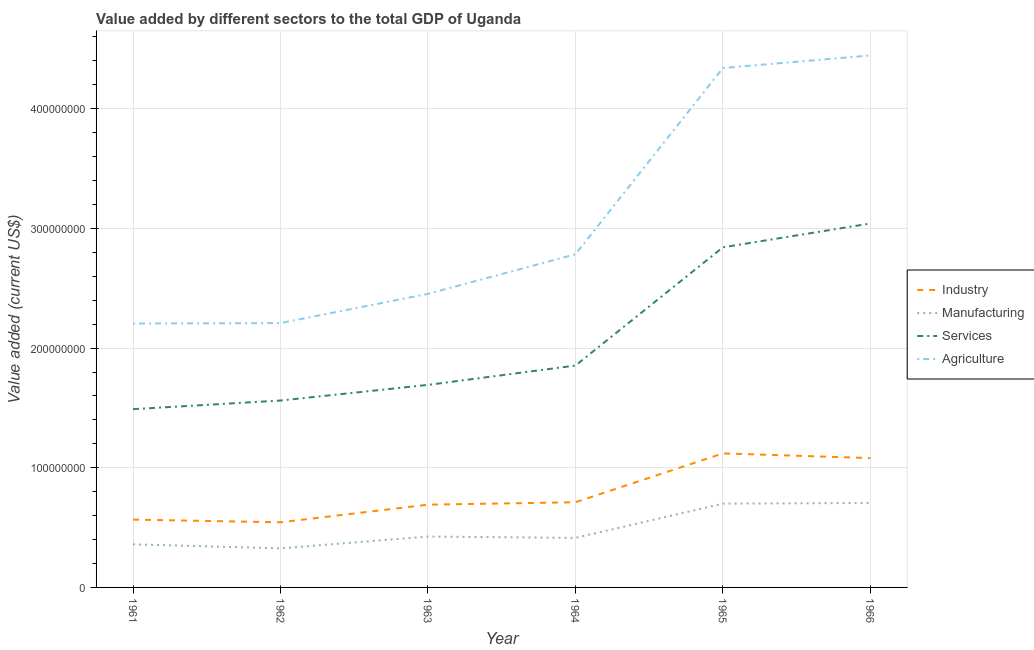What is the value added by agricultural sector in 1966?
Provide a succinct answer. 4.44e+08. Across all years, what is the maximum value added by agricultural sector?
Your answer should be compact. 4.44e+08. Across all years, what is the minimum value added by manufacturing sector?
Make the answer very short. 3.26e+07. In which year was the value added by industrial sector maximum?
Provide a succinct answer. 1965. What is the total value added by services sector in the graph?
Provide a succinct answer. 1.25e+09. What is the difference between the value added by industrial sector in 1962 and that in 1963?
Keep it short and to the point. -1.47e+07. What is the difference between the value added by agricultural sector in 1962 and the value added by industrial sector in 1964?
Ensure brevity in your answer.  1.50e+08. What is the average value added by manufacturing sector per year?
Give a very brief answer. 4.89e+07. In the year 1963, what is the difference between the value added by agricultural sector and value added by services sector?
Your answer should be compact. 7.61e+07. In how many years, is the value added by services sector greater than 100000000 US$?
Offer a terse response. 6. What is the ratio of the value added by industrial sector in 1965 to that in 1966?
Your response must be concise. 1.04. Is the value added by agricultural sector in 1962 less than that in 1965?
Your answer should be very brief. Yes. What is the difference between the highest and the second highest value added by agricultural sector?
Provide a succinct answer. 1.05e+07. What is the difference between the highest and the lowest value added by industrial sector?
Give a very brief answer. 5.76e+07. In how many years, is the value added by manufacturing sector greater than the average value added by manufacturing sector taken over all years?
Your response must be concise. 2. Is it the case that in every year, the sum of the value added by industrial sector and value added by manufacturing sector is greater than the value added by services sector?
Keep it short and to the point. No. Does the value added by agricultural sector monotonically increase over the years?
Provide a short and direct response. Yes. Is the value added by services sector strictly less than the value added by agricultural sector over the years?
Provide a succinct answer. Yes. How many lines are there?
Provide a short and direct response. 4. What is the difference between two consecutive major ticks on the Y-axis?
Offer a very short reply. 1.00e+08. How many legend labels are there?
Your answer should be compact. 4. How are the legend labels stacked?
Give a very brief answer. Vertical. What is the title of the graph?
Provide a short and direct response. Value added by different sectors to the total GDP of Uganda. What is the label or title of the X-axis?
Offer a very short reply. Year. What is the label or title of the Y-axis?
Offer a terse response. Value added (current US$). What is the Value added (current US$) in Industry in 1961?
Give a very brief answer. 5.67e+07. What is the Value added (current US$) of Manufacturing in 1961?
Give a very brief answer. 3.60e+07. What is the Value added (current US$) of Services in 1961?
Give a very brief answer. 1.49e+08. What is the Value added (current US$) in Agriculture in 1961?
Offer a very short reply. 2.20e+08. What is the Value added (current US$) of Industry in 1962?
Your answer should be very brief. 5.44e+07. What is the Value added (current US$) in Manufacturing in 1962?
Provide a succinct answer. 3.26e+07. What is the Value added (current US$) in Services in 1962?
Give a very brief answer. 1.56e+08. What is the Value added (current US$) of Agriculture in 1962?
Keep it short and to the point. 2.21e+08. What is the Value added (current US$) in Industry in 1963?
Your answer should be very brief. 6.91e+07. What is the Value added (current US$) of Manufacturing in 1963?
Make the answer very short. 4.25e+07. What is the Value added (current US$) of Services in 1963?
Keep it short and to the point. 1.69e+08. What is the Value added (current US$) in Agriculture in 1963?
Your answer should be compact. 2.45e+08. What is the Value added (current US$) in Industry in 1964?
Ensure brevity in your answer.  7.12e+07. What is the Value added (current US$) in Manufacturing in 1964?
Provide a succinct answer. 4.14e+07. What is the Value added (current US$) of Services in 1964?
Your answer should be compact. 1.85e+08. What is the Value added (current US$) of Agriculture in 1964?
Keep it short and to the point. 2.78e+08. What is the Value added (current US$) in Industry in 1965?
Make the answer very short. 1.12e+08. What is the Value added (current US$) in Manufacturing in 1965?
Your answer should be very brief. 7.00e+07. What is the Value added (current US$) in Services in 1965?
Your answer should be very brief. 2.84e+08. What is the Value added (current US$) of Agriculture in 1965?
Provide a short and direct response. 4.34e+08. What is the Value added (current US$) in Industry in 1966?
Offer a very short reply. 1.08e+08. What is the Value added (current US$) in Manufacturing in 1966?
Your answer should be very brief. 7.06e+07. What is the Value added (current US$) in Services in 1966?
Provide a succinct answer. 3.04e+08. What is the Value added (current US$) in Agriculture in 1966?
Your answer should be compact. 4.44e+08. Across all years, what is the maximum Value added (current US$) of Industry?
Ensure brevity in your answer.  1.12e+08. Across all years, what is the maximum Value added (current US$) in Manufacturing?
Your response must be concise. 7.06e+07. Across all years, what is the maximum Value added (current US$) of Services?
Your answer should be compact. 3.04e+08. Across all years, what is the maximum Value added (current US$) of Agriculture?
Offer a terse response. 4.44e+08. Across all years, what is the minimum Value added (current US$) in Industry?
Make the answer very short. 5.44e+07. Across all years, what is the minimum Value added (current US$) in Manufacturing?
Make the answer very short. 3.26e+07. Across all years, what is the minimum Value added (current US$) in Services?
Give a very brief answer. 1.49e+08. Across all years, what is the minimum Value added (current US$) in Agriculture?
Ensure brevity in your answer.  2.20e+08. What is the total Value added (current US$) in Industry in the graph?
Keep it short and to the point. 4.71e+08. What is the total Value added (current US$) in Manufacturing in the graph?
Your answer should be compact. 2.93e+08. What is the total Value added (current US$) in Services in the graph?
Offer a very short reply. 1.25e+09. What is the total Value added (current US$) of Agriculture in the graph?
Ensure brevity in your answer.  1.84e+09. What is the difference between the Value added (current US$) of Industry in 1961 and that in 1962?
Your answer should be compact. 2.24e+06. What is the difference between the Value added (current US$) in Manufacturing in 1961 and that in 1962?
Your response must be concise. 3.39e+06. What is the difference between the Value added (current US$) in Services in 1961 and that in 1962?
Make the answer very short. -7.22e+06. What is the difference between the Value added (current US$) of Agriculture in 1961 and that in 1962?
Ensure brevity in your answer.  -4.07e+05. What is the difference between the Value added (current US$) in Industry in 1961 and that in 1963?
Provide a succinct answer. -1.25e+07. What is the difference between the Value added (current US$) of Manufacturing in 1961 and that in 1963?
Your response must be concise. -6.48e+06. What is the difference between the Value added (current US$) in Services in 1961 and that in 1963?
Keep it short and to the point. -2.03e+07. What is the difference between the Value added (current US$) in Agriculture in 1961 and that in 1963?
Your answer should be very brief. -2.48e+07. What is the difference between the Value added (current US$) in Industry in 1961 and that in 1964?
Give a very brief answer. -1.45e+07. What is the difference between the Value added (current US$) of Manufacturing in 1961 and that in 1964?
Provide a short and direct response. -5.37e+06. What is the difference between the Value added (current US$) in Services in 1961 and that in 1964?
Provide a succinct answer. -3.64e+07. What is the difference between the Value added (current US$) of Agriculture in 1961 and that in 1964?
Offer a terse response. -5.79e+07. What is the difference between the Value added (current US$) of Industry in 1961 and that in 1965?
Provide a succinct answer. -5.53e+07. What is the difference between the Value added (current US$) in Manufacturing in 1961 and that in 1965?
Keep it short and to the point. -3.40e+07. What is the difference between the Value added (current US$) in Services in 1961 and that in 1965?
Your answer should be compact. -1.35e+08. What is the difference between the Value added (current US$) in Agriculture in 1961 and that in 1965?
Your response must be concise. -2.13e+08. What is the difference between the Value added (current US$) in Industry in 1961 and that in 1966?
Give a very brief answer. -5.14e+07. What is the difference between the Value added (current US$) in Manufacturing in 1961 and that in 1966?
Offer a very short reply. -3.45e+07. What is the difference between the Value added (current US$) in Services in 1961 and that in 1966?
Provide a short and direct response. -1.55e+08. What is the difference between the Value added (current US$) of Agriculture in 1961 and that in 1966?
Provide a succinct answer. -2.24e+08. What is the difference between the Value added (current US$) in Industry in 1962 and that in 1963?
Ensure brevity in your answer.  -1.47e+07. What is the difference between the Value added (current US$) in Manufacturing in 1962 and that in 1963?
Your answer should be compact. -9.87e+06. What is the difference between the Value added (current US$) in Services in 1962 and that in 1963?
Give a very brief answer. -1.31e+07. What is the difference between the Value added (current US$) of Agriculture in 1962 and that in 1963?
Your answer should be compact. -2.44e+07. What is the difference between the Value added (current US$) in Industry in 1962 and that in 1964?
Keep it short and to the point. -1.68e+07. What is the difference between the Value added (current US$) in Manufacturing in 1962 and that in 1964?
Your answer should be very brief. -8.76e+06. What is the difference between the Value added (current US$) of Services in 1962 and that in 1964?
Give a very brief answer. -2.92e+07. What is the difference between the Value added (current US$) in Agriculture in 1962 and that in 1964?
Offer a terse response. -5.75e+07. What is the difference between the Value added (current US$) of Industry in 1962 and that in 1965?
Keep it short and to the point. -5.76e+07. What is the difference between the Value added (current US$) of Manufacturing in 1962 and that in 1965?
Offer a terse response. -3.74e+07. What is the difference between the Value added (current US$) of Services in 1962 and that in 1965?
Ensure brevity in your answer.  -1.28e+08. What is the difference between the Value added (current US$) in Agriculture in 1962 and that in 1965?
Ensure brevity in your answer.  -2.13e+08. What is the difference between the Value added (current US$) in Industry in 1962 and that in 1966?
Your answer should be very brief. -5.37e+07. What is the difference between the Value added (current US$) of Manufacturing in 1962 and that in 1966?
Keep it short and to the point. -3.79e+07. What is the difference between the Value added (current US$) in Services in 1962 and that in 1966?
Make the answer very short. -1.48e+08. What is the difference between the Value added (current US$) in Agriculture in 1962 and that in 1966?
Your response must be concise. -2.24e+08. What is the difference between the Value added (current US$) in Industry in 1963 and that in 1964?
Provide a succinct answer. -2.03e+06. What is the difference between the Value added (current US$) of Manufacturing in 1963 and that in 1964?
Your response must be concise. 1.11e+06. What is the difference between the Value added (current US$) in Services in 1963 and that in 1964?
Provide a short and direct response. -1.61e+07. What is the difference between the Value added (current US$) in Agriculture in 1963 and that in 1964?
Keep it short and to the point. -3.31e+07. What is the difference between the Value added (current US$) of Industry in 1963 and that in 1965?
Keep it short and to the point. -4.29e+07. What is the difference between the Value added (current US$) of Manufacturing in 1963 and that in 1965?
Provide a succinct answer. -2.75e+07. What is the difference between the Value added (current US$) of Services in 1963 and that in 1965?
Your response must be concise. -1.15e+08. What is the difference between the Value added (current US$) in Agriculture in 1963 and that in 1965?
Make the answer very short. -1.89e+08. What is the difference between the Value added (current US$) of Industry in 1963 and that in 1966?
Your answer should be compact. -3.89e+07. What is the difference between the Value added (current US$) of Manufacturing in 1963 and that in 1966?
Offer a very short reply. -2.81e+07. What is the difference between the Value added (current US$) in Services in 1963 and that in 1966?
Offer a very short reply. -1.35e+08. What is the difference between the Value added (current US$) of Agriculture in 1963 and that in 1966?
Provide a succinct answer. -1.99e+08. What is the difference between the Value added (current US$) in Industry in 1964 and that in 1965?
Your answer should be very brief. -4.08e+07. What is the difference between the Value added (current US$) of Manufacturing in 1964 and that in 1965?
Give a very brief answer. -2.86e+07. What is the difference between the Value added (current US$) of Services in 1964 and that in 1965?
Ensure brevity in your answer.  -9.88e+07. What is the difference between the Value added (current US$) in Agriculture in 1964 and that in 1965?
Your answer should be compact. -1.56e+08. What is the difference between the Value added (current US$) in Industry in 1964 and that in 1966?
Offer a terse response. -3.69e+07. What is the difference between the Value added (current US$) in Manufacturing in 1964 and that in 1966?
Ensure brevity in your answer.  -2.92e+07. What is the difference between the Value added (current US$) of Services in 1964 and that in 1966?
Ensure brevity in your answer.  -1.19e+08. What is the difference between the Value added (current US$) of Agriculture in 1964 and that in 1966?
Your answer should be very brief. -1.66e+08. What is the difference between the Value added (current US$) in Industry in 1965 and that in 1966?
Ensure brevity in your answer.  3.92e+06. What is the difference between the Value added (current US$) of Manufacturing in 1965 and that in 1966?
Provide a short and direct response. -5.60e+05. What is the difference between the Value added (current US$) of Services in 1965 and that in 1966?
Make the answer very short. -1.99e+07. What is the difference between the Value added (current US$) in Agriculture in 1965 and that in 1966?
Provide a short and direct response. -1.05e+07. What is the difference between the Value added (current US$) of Industry in 1961 and the Value added (current US$) of Manufacturing in 1962?
Give a very brief answer. 2.40e+07. What is the difference between the Value added (current US$) in Industry in 1961 and the Value added (current US$) in Services in 1962?
Your answer should be compact. -9.95e+07. What is the difference between the Value added (current US$) of Industry in 1961 and the Value added (current US$) of Agriculture in 1962?
Provide a short and direct response. -1.64e+08. What is the difference between the Value added (current US$) of Manufacturing in 1961 and the Value added (current US$) of Services in 1962?
Provide a short and direct response. -1.20e+08. What is the difference between the Value added (current US$) of Manufacturing in 1961 and the Value added (current US$) of Agriculture in 1962?
Offer a very short reply. -1.85e+08. What is the difference between the Value added (current US$) in Services in 1961 and the Value added (current US$) in Agriculture in 1962?
Make the answer very short. -7.20e+07. What is the difference between the Value added (current US$) in Industry in 1961 and the Value added (current US$) in Manufacturing in 1963?
Your answer should be very brief. 1.42e+07. What is the difference between the Value added (current US$) of Industry in 1961 and the Value added (current US$) of Services in 1963?
Provide a succinct answer. -1.13e+08. What is the difference between the Value added (current US$) in Industry in 1961 and the Value added (current US$) in Agriculture in 1963?
Your answer should be very brief. -1.89e+08. What is the difference between the Value added (current US$) in Manufacturing in 1961 and the Value added (current US$) in Services in 1963?
Ensure brevity in your answer.  -1.33e+08. What is the difference between the Value added (current US$) in Manufacturing in 1961 and the Value added (current US$) in Agriculture in 1963?
Your response must be concise. -2.09e+08. What is the difference between the Value added (current US$) of Services in 1961 and the Value added (current US$) of Agriculture in 1963?
Make the answer very short. -9.64e+07. What is the difference between the Value added (current US$) in Industry in 1961 and the Value added (current US$) in Manufacturing in 1964?
Your answer should be very brief. 1.53e+07. What is the difference between the Value added (current US$) of Industry in 1961 and the Value added (current US$) of Services in 1964?
Offer a terse response. -1.29e+08. What is the difference between the Value added (current US$) of Industry in 1961 and the Value added (current US$) of Agriculture in 1964?
Provide a succinct answer. -2.22e+08. What is the difference between the Value added (current US$) of Manufacturing in 1961 and the Value added (current US$) of Services in 1964?
Provide a succinct answer. -1.49e+08. What is the difference between the Value added (current US$) in Manufacturing in 1961 and the Value added (current US$) in Agriculture in 1964?
Your answer should be very brief. -2.42e+08. What is the difference between the Value added (current US$) of Services in 1961 and the Value added (current US$) of Agriculture in 1964?
Ensure brevity in your answer.  -1.29e+08. What is the difference between the Value added (current US$) of Industry in 1961 and the Value added (current US$) of Manufacturing in 1965?
Offer a terse response. -1.33e+07. What is the difference between the Value added (current US$) of Industry in 1961 and the Value added (current US$) of Services in 1965?
Keep it short and to the point. -2.28e+08. What is the difference between the Value added (current US$) of Industry in 1961 and the Value added (current US$) of Agriculture in 1965?
Give a very brief answer. -3.77e+08. What is the difference between the Value added (current US$) of Manufacturing in 1961 and the Value added (current US$) of Services in 1965?
Ensure brevity in your answer.  -2.48e+08. What is the difference between the Value added (current US$) in Manufacturing in 1961 and the Value added (current US$) in Agriculture in 1965?
Make the answer very short. -3.98e+08. What is the difference between the Value added (current US$) in Services in 1961 and the Value added (current US$) in Agriculture in 1965?
Your answer should be very brief. -2.85e+08. What is the difference between the Value added (current US$) of Industry in 1961 and the Value added (current US$) of Manufacturing in 1966?
Offer a very short reply. -1.39e+07. What is the difference between the Value added (current US$) of Industry in 1961 and the Value added (current US$) of Services in 1966?
Offer a very short reply. -2.47e+08. What is the difference between the Value added (current US$) of Industry in 1961 and the Value added (current US$) of Agriculture in 1966?
Ensure brevity in your answer.  -3.88e+08. What is the difference between the Value added (current US$) in Manufacturing in 1961 and the Value added (current US$) in Services in 1966?
Your answer should be very brief. -2.68e+08. What is the difference between the Value added (current US$) of Manufacturing in 1961 and the Value added (current US$) of Agriculture in 1966?
Provide a short and direct response. -4.08e+08. What is the difference between the Value added (current US$) in Services in 1961 and the Value added (current US$) in Agriculture in 1966?
Your answer should be very brief. -2.96e+08. What is the difference between the Value added (current US$) of Industry in 1962 and the Value added (current US$) of Manufacturing in 1963?
Provide a short and direct response. 1.19e+07. What is the difference between the Value added (current US$) of Industry in 1962 and the Value added (current US$) of Services in 1963?
Give a very brief answer. -1.15e+08. What is the difference between the Value added (current US$) in Industry in 1962 and the Value added (current US$) in Agriculture in 1963?
Offer a terse response. -1.91e+08. What is the difference between the Value added (current US$) of Manufacturing in 1962 and the Value added (current US$) of Services in 1963?
Offer a terse response. -1.37e+08. What is the difference between the Value added (current US$) of Manufacturing in 1962 and the Value added (current US$) of Agriculture in 1963?
Your answer should be very brief. -2.13e+08. What is the difference between the Value added (current US$) in Services in 1962 and the Value added (current US$) in Agriculture in 1963?
Ensure brevity in your answer.  -8.91e+07. What is the difference between the Value added (current US$) of Industry in 1962 and the Value added (current US$) of Manufacturing in 1964?
Your answer should be very brief. 1.30e+07. What is the difference between the Value added (current US$) in Industry in 1962 and the Value added (current US$) in Services in 1964?
Your response must be concise. -1.31e+08. What is the difference between the Value added (current US$) in Industry in 1962 and the Value added (current US$) in Agriculture in 1964?
Offer a terse response. -2.24e+08. What is the difference between the Value added (current US$) of Manufacturing in 1962 and the Value added (current US$) of Services in 1964?
Offer a very short reply. -1.53e+08. What is the difference between the Value added (current US$) in Manufacturing in 1962 and the Value added (current US$) in Agriculture in 1964?
Give a very brief answer. -2.46e+08. What is the difference between the Value added (current US$) of Services in 1962 and the Value added (current US$) of Agriculture in 1964?
Keep it short and to the point. -1.22e+08. What is the difference between the Value added (current US$) of Industry in 1962 and the Value added (current US$) of Manufacturing in 1965?
Keep it short and to the point. -1.56e+07. What is the difference between the Value added (current US$) in Industry in 1962 and the Value added (current US$) in Services in 1965?
Provide a succinct answer. -2.30e+08. What is the difference between the Value added (current US$) in Industry in 1962 and the Value added (current US$) in Agriculture in 1965?
Your answer should be very brief. -3.80e+08. What is the difference between the Value added (current US$) of Manufacturing in 1962 and the Value added (current US$) of Services in 1965?
Offer a very short reply. -2.52e+08. What is the difference between the Value added (current US$) of Manufacturing in 1962 and the Value added (current US$) of Agriculture in 1965?
Provide a succinct answer. -4.01e+08. What is the difference between the Value added (current US$) of Services in 1962 and the Value added (current US$) of Agriculture in 1965?
Offer a terse response. -2.78e+08. What is the difference between the Value added (current US$) in Industry in 1962 and the Value added (current US$) in Manufacturing in 1966?
Provide a short and direct response. -1.61e+07. What is the difference between the Value added (current US$) of Industry in 1962 and the Value added (current US$) of Services in 1966?
Keep it short and to the point. -2.50e+08. What is the difference between the Value added (current US$) of Industry in 1962 and the Value added (current US$) of Agriculture in 1966?
Ensure brevity in your answer.  -3.90e+08. What is the difference between the Value added (current US$) of Manufacturing in 1962 and the Value added (current US$) of Services in 1966?
Provide a succinct answer. -2.71e+08. What is the difference between the Value added (current US$) in Manufacturing in 1962 and the Value added (current US$) in Agriculture in 1966?
Provide a succinct answer. -4.12e+08. What is the difference between the Value added (current US$) of Services in 1962 and the Value added (current US$) of Agriculture in 1966?
Offer a very short reply. -2.88e+08. What is the difference between the Value added (current US$) in Industry in 1963 and the Value added (current US$) in Manufacturing in 1964?
Keep it short and to the point. 2.77e+07. What is the difference between the Value added (current US$) in Industry in 1963 and the Value added (current US$) in Services in 1964?
Offer a terse response. -1.16e+08. What is the difference between the Value added (current US$) in Industry in 1963 and the Value added (current US$) in Agriculture in 1964?
Make the answer very short. -2.09e+08. What is the difference between the Value added (current US$) in Manufacturing in 1963 and the Value added (current US$) in Services in 1964?
Your response must be concise. -1.43e+08. What is the difference between the Value added (current US$) in Manufacturing in 1963 and the Value added (current US$) in Agriculture in 1964?
Give a very brief answer. -2.36e+08. What is the difference between the Value added (current US$) of Services in 1963 and the Value added (current US$) of Agriculture in 1964?
Ensure brevity in your answer.  -1.09e+08. What is the difference between the Value added (current US$) in Industry in 1963 and the Value added (current US$) in Manufacturing in 1965?
Ensure brevity in your answer.  -8.55e+05. What is the difference between the Value added (current US$) of Industry in 1963 and the Value added (current US$) of Services in 1965?
Keep it short and to the point. -2.15e+08. What is the difference between the Value added (current US$) in Industry in 1963 and the Value added (current US$) in Agriculture in 1965?
Give a very brief answer. -3.65e+08. What is the difference between the Value added (current US$) of Manufacturing in 1963 and the Value added (current US$) of Services in 1965?
Make the answer very short. -2.42e+08. What is the difference between the Value added (current US$) of Manufacturing in 1963 and the Value added (current US$) of Agriculture in 1965?
Offer a terse response. -3.91e+08. What is the difference between the Value added (current US$) of Services in 1963 and the Value added (current US$) of Agriculture in 1965?
Make the answer very short. -2.65e+08. What is the difference between the Value added (current US$) in Industry in 1963 and the Value added (current US$) in Manufacturing in 1966?
Your answer should be very brief. -1.41e+06. What is the difference between the Value added (current US$) of Industry in 1963 and the Value added (current US$) of Services in 1966?
Offer a terse response. -2.35e+08. What is the difference between the Value added (current US$) of Industry in 1963 and the Value added (current US$) of Agriculture in 1966?
Ensure brevity in your answer.  -3.75e+08. What is the difference between the Value added (current US$) in Manufacturing in 1963 and the Value added (current US$) in Services in 1966?
Provide a short and direct response. -2.62e+08. What is the difference between the Value added (current US$) in Manufacturing in 1963 and the Value added (current US$) in Agriculture in 1966?
Your answer should be very brief. -4.02e+08. What is the difference between the Value added (current US$) of Services in 1963 and the Value added (current US$) of Agriculture in 1966?
Make the answer very short. -2.75e+08. What is the difference between the Value added (current US$) of Industry in 1964 and the Value added (current US$) of Manufacturing in 1965?
Keep it short and to the point. 1.18e+06. What is the difference between the Value added (current US$) of Industry in 1964 and the Value added (current US$) of Services in 1965?
Keep it short and to the point. -2.13e+08. What is the difference between the Value added (current US$) in Industry in 1964 and the Value added (current US$) in Agriculture in 1965?
Your answer should be very brief. -3.63e+08. What is the difference between the Value added (current US$) of Manufacturing in 1964 and the Value added (current US$) of Services in 1965?
Your answer should be compact. -2.43e+08. What is the difference between the Value added (current US$) in Manufacturing in 1964 and the Value added (current US$) in Agriculture in 1965?
Offer a terse response. -3.93e+08. What is the difference between the Value added (current US$) in Services in 1964 and the Value added (current US$) in Agriculture in 1965?
Provide a succinct answer. -2.49e+08. What is the difference between the Value added (current US$) in Industry in 1964 and the Value added (current US$) in Manufacturing in 1966?
Your answer should be very brief. 6.20e+05. What is the difference between the Value added (current US$) of Industry in 1964 and the Value added (current US$) of Services in 1966?
Provide a short and direct response. -2.33e+08. What is the difference between the Value added (current US$) in Industry in 1964 and the Value added (current US$) in Agriculture in 1966?
Your answer should be compact. -3.73e+08. What is the difference between the Value added (current US$) in Manufacturing in 1964 and the Value added (current US$) in Services in 1966?
Provide a short and direct response. -2.63e+08. What is the difference between the Value added (current US$) of Manufacturing in 1964 and the Value added (current US$) of Agriculture in 1966?
Ensure brevity in your answer.  -4.03e+08. What is the difference between the Value added (current US$) in Services in 1964 and the Value added (current US$) in Agriculture in 1966?
Your response must be concise. -2.59e+08. What is the difference between the Value added (current US$) of Industry in 1965 and the Value added (current US$) of Manufacturing in 1966?
Offer a terse response. 4.14e+07. What is the difference between the Value added (current US$) in Industry in 1965 and the Value added (current US$) in Services in 1966?
Provide a short and direct response. -1.92e+08. What is the difference between the Value added (current US$) in Industry in 1965 and the Value added (current US$) in Agriculture in 1966?
Offer a terse response. -3.32e+08. What is the difference between the Value added (current US$) in Manufacturing in 1965 and the Value added (current US$) in Services in 1966?
Offer a terse response. -2.34e+08. What is the difference between the Value added (current US$) in Manufacturing in 1965 and the Value added (current US$) in Agriculture in 1966?
Your answer should be compact. -3.74e+08. What is the difference between the Value added (current US$) in Services in 1965 and the Value added (current US$) in Agriculture in 1966?
Give a very brief answer. -1.60e+08. What is the average Value added (current US$) in Industry per year?
Your answer should be very brief. 7.86e+07. What is the average Value added (current US$) of Manufacturing per year?
Offer a very short reply. 4.89e+07. What is the average Value added (current US$) of Services per year?
Your answer should be very brief. 2.08e+08. What is the average Value added (current US$) in Agriculture per year?
Your response must be concise. 3.07e+08. In the year 1961, what is the difference between the Value added (current US$) in Industry and Value added (current US$) in Manufacturing?
Make the answer very short. 2.06e+07. In the year 1961, what is the difference between the Value added (current US$) of Industry and Value added (current US$) of Services?
Keep it short and to the point. -9.23e+07. In the year 1961, what is the difference between the Value added (current US$) of Industry and Value added (current US$) of Agriculture?
Provide a short and direct response. -1.64e+08. In the year 1961, what is the difference between the Value added (current US$) of Manufacturing and Value added (current US$) of Services?
Ensure brevity in your answer.  -1.13e+08. In the year 1961, what is the difference between the Value added (current US$) of Manufacturing and Value added (current US$) of Agriculture?
Your response must be concise. -1.84e+08. In the year 1961, what is the difference between the Value added (current US$) of Services and Value added (current US$) of Agriculture?
Keep it short and to the point. -7.15e+07. In the year 1962, what is the difference between the Value added (current US$) in Industry and Value added (current US$) in Manufacturing?
Offer a very short reply. 2.18e+07. In the year 1962, what is the difference between the Value added (current US$) in Industry and Value added (current US$) in Services?
Your response must be concise. -1.02e+08. In the year 1962, what is the difference between the Value added (current US$) of Industry and Value added (current US$) of Agriculture?
Provide a short and direct response. -1.66e+08. In the year 1962, what is the difference between the Value added (current US$) of Manufacturing and Value added (current US$) of Services?
Offer a very short reply. -1.24e+08. In the year 1962, what is the difference between the Value added (current US$) in Manufacturing and Value added (current US$) in Agriculture?
Keep it short and to the point. -1.88e+08. In the year 1962, what is the difference between the Value added (current US$) of Services and Value added (current US$) of Agriculture?
Provide a succinct answer. -6.47e+07. In the year 1963, what is the difference between the Value added (current US$) in Industry and Value added (current US$) in Manufacturing?
Your response must be concise. 2.66e+07. In the year 1963, what is the difference between the Value added (current US$) in Industry and Value added (current US$) in Services?
Offer a very short reply. -1.00e+08. In the year 1963, what is the difference between the Value added (current US$) in Industry and Value added (current US$) in Agriculture?
Your answer should be compact. -1.76e+08. In the year 1963, what is the difference between the Value added (current US$) in Manufacturing and Value added (current US$) in Services?
Provide a succinct answer. -1.27e+08. In the year 1963, what is the difference between the Value added (current US$) of Manufacturing and Value added (current US$) of Agriculture?
Your answer should be very brief. -2.03e+08. In the year 1963, what is the difference between the Value added (current US$) in Services and Value added (current US$) in Agriculture?
Keep it short and to the point. -7.61e+07. In the year 1964, what is the difference between the Value added (current US$) in Industry and Value added (current US$) in Manufacturing?
Keep it short and to the point. 2.98e+07. In the year 1964, what is the difference between the Value added (current US$) of Industry and Value added (current US$) of Services?
Your answer should be very brief. -1.14e+08. In the year 1964, what is the difference between the Value added (current US$) of Industry and Value added (current US$) of Agriculture?
Provide a succinct answer. -2.07e+08. In the year 1964, what is the difference between the Value added (current US$) of Manufacturing and Value added (current US$) of Services?
Keep it short and to the point. -1.44e+08. In the year 1964, what is the difference between the Value added (current US$) in Manufacturing and Value added (current US$) in Agriculture?
Ensure brevity in your answer.  -2.37e+08. In the year 1964, what is the difference between the Value added (current US$) of Services and Value added (current US$) of Agriculture?
Offer a very short reply. -9.30e+07. In the year 1965, what is the difference between the Value added (current US$) in Industry and Value added (current US$) in Manufacturing?
Your answer should be compact. 4.20e+07. In the year 1965, what is the difference between the Value added (current US$) of Industry and Value added (current US$) of Services?
Make the answer very short. -1.72e+08. In the year 1965, what is the difference between the Value added (current US$) in Industry and Value added (current US$) in Agriculture?
Your answer should be very brief. -3.22e+08. In the year 1965, what is the difference between the Value added (current US$) of Manufacturing and Value added (current US$) of Services?
Give a very brief answer. -2.14e+08. In the year 1965, what is the difference between the Value added (current US$) in Manufacturing and Value added (current US$) in Agriculture?
Your answer should be compact. -3.64e+08. In the year 1965, what is the difference between the Value added (current US$) of Services and Value added (current US$) of Agriculture?
Make the answer very short. -1.50e+08. In the year 1966, what is the difference between the Value added (current US$) in Industry and Value added (current US$) in Manufacturing?
Give a very brief answer. 3.75e+07. In the year 1966, what is the difference between the Value added (current US$) of Industry and Value added (current US$) of Services?
Your response must be concise. -1.96e+08. In the year 1966, what is the difference between the Value added (current US$) of Industry and Value added (current US$) of Agriculture?
Your answer should be compact. -3.36e+08. In the year 1966, what is the difference between the Value added (current US$) in Manufacturing and Value added (current US$) in Services?
Your response must be concise. -2.34e+08. In the year 1966, what is the difference between the Value added (current US$) in Manufacturing and Value added (current US$) in Agriculture?
Offer a terse response. -3.74e+08. In the year 1966, what is the difference between the Value added (current US$) in Services and Value added (current US$) in Agriculture?
Ensure brevity in your answer.  -1.40e+08. What is the ratio of the Value added (current US$) in Industry in 1961 to that in 1962?
Ensure brevity in your answer.  1.04. What is the ratio of the Value added (current US$) in Manufacturing in 1961 to that in 1962?
Provide a short and direct response. 1.1. What is the ratio of the Value added (current US$) of Services in 1961 to that in 1962?
Give a very brief answer. 0.95. What is the ratio of the Value added (current US$) in Agriculture in 1961 to that in 1962?
Provide a short and direct response. 1. What is the ratio of the Value added (current US$) in Industry in 1961 to that in 1963?
Provide a succinct answer. 0.82. What is the ratio of the Value added (current US$) in Manufacturing in 1961 to that in 1963?
Offer a terse response. 0.85. What is the ratio of the Value added (current US$) of Services in 1961 to that in 1963?
Your answer should be very brief. 0.88. What is the ratio of the Value added (current US$) of Agriculture in 1961 to that in 1963?
Ensure brevity in your answer.  0.9. What is the ratio of the Value added (current US$) in Industry in 1961 to that in 1964?
Your answer should be compact. 0.8. What is the ratio of the Value added (current US$) in Manufacturing in 1961 to that in 1964?
Keep it short and to the point. 0.87. What is the ratio of the Value added (current US$) of Services in 1961 to that in 1964?
Make the answer very short. 0.8. What is the ratio of the Value added (current US$) of Agriculture in 1961 to that in 1964?
Ensure brevity in your answer.  0.79. What is the ratio of the Value added (current US$) of Industry in 1961 to that in 1965?
Keep it short and to the point. 0.51. What is the ratio of the Value added (current US$) in Manufacturing in 1961 to that in 1965?
Make the answer very short. 0.51. What is the ratio of the Value added (current US$) of Services in 1961 to that in 1965?
Provide a succinct answer. 0.52. What is the ratio of the Value added (current US$) in Agriculture in 1961 to that in 1965?
Offer a very short reply. 0.51. What is the ratio of the Value added (current US$) in Industry in 1961 to that in 1966?
Your answer should be very brief. 0.52. What is the ratio of the Value added (current US$) in Manufacturing in 1961 to that in 1966?
Your response must be concise. 0.51. What is the ratio of the Value added (current US$) of Services in 1961 to that in 1966?
Your answer should be compact. 0.49. What is the ratio of the Value added (current US$) of Agriculture in 1961 to that in 1966?
Keep it short and to the point. 0.5. What is the ratio of the Value added (current US$) of Industry in 1962 to that in 1963?
Offer a very short reply. 0.79. What is the ratio of the Value added (current US$) in Manufacturing in 1962 to that in 1963?
Give a very brief answer. 0.77. What is the ratio of the Value added (current US$) in Services in 1962 to that in 1963?
Your response must be concise. 0.92. What is the ratio of the Value added (current US$) of Agriculture in 1962 to that in 1963?
Ensure brevity in your answer.  0.9. What is the ratio of the Value added (current US$) in Industry in 1962 to that in 1964?
Provide a short and direct response. 0.76. What is the ratio of the Value added (current US$) of Manufacturing in 1962 to that in 1964?
Keep it short and to the point. 0.79. What is the ratio of the Value added (current US$) in Services in 1962 to that in 1964?
Provide a short and direct response. 0.84. What is the ratio of the Value added (current US$) in Agriculture in 1962 to that in 1964?
Offer a terse response. 0.79. What is the ratio of the Value added (current US$) in Industry in 1962 to that in 1965?
Ensure brevity in your answer.  0.49. What is the ratio of the Value added (current US$) of Manufacturing in 1962 to that in 1965?
Keep it short and to the point. 0.47. What is the ratio of the Value added (current US$) in Services in 1962 to that in 1965?
Keep it short and to the point. 0.55. What is the ratio of the Value added (current US$) in Agriculture in 1962 to that in 1965?
Provide a short and direct response. 0.51. What is the ratio of the Value added (current US$) of Industry in 1962 to that in 1966?
Your answer should be compact. 0.5. What is the ratio of the Value added (current US$) of Manufacturing in 1962 to that in 1966?
Make the answer very short. 0.46. What is the ratio of the Value added (current US$) in Services in 1962 to that in 1966?
Provide a succinct answer. 0.51. What is the ratio of the Value added (current US$) of Agriculture in 1962 to that in 1966?
Offer a very short reply. 0.5. What is the ratio of the Value added (current US$) of Industry in 1963 to that in 1964?
Provide a short and direct response. 0.97. What is the ratio of the Value added (current US$) in Manufacturing in 1963 to that in 1964?
Make the answer very short. 1.03. What is the ratio of the Value added (current US$) in Services in 1963 to that in 1964?
Offer a very short reply. 0.91. What is the ratio of the Value added (current US$) of Agriculture in 1963 to that in 1964?
Make the answer very short. 0.88. What is the ratio of the Value added (current US$) of Industry in 1963 to that in 1965?
Ensure brevity in your answer.  0.62. What is the ratio of the Value added (current US$) of Manufacturing in 1963 to that in 1965?
Your response must be concise. 0.61. What is the ratio of the Value added (current US$) of Services in 1963 to that in 1965?
Your answer should be compact. 0.6. What is the ratio of the Value added (current US$) of Agriculture in 1963 to that in 1965?
Ensure brevity in your answer.  0.57. What is the ratio of the Value added (current US$) in Industry in 1963 to that in 1966?
Offer a very short reply. 0.64. What is the ratio of the Value added (current US$) in Manufacturing in 1963 to that in 1966?
Your answer should be very brief. 0.6. What is the ratio of the Value added (current US$) in Services in 1963 to that in 1966?
Your response must be concise. 0.56. What is the ratio of the Value added (current US$) in Agriculture in 1963 to that in 1966?
Make the answer very short. 0.55. What is the ratio of the Value added (current US$) in Industry in 1964 to that in 1965?
Keep it short and to the point. 0.64. What is the ratio of the Value added (current US$) in Manufacturing in 1964 to that in 1965?
Your answer should be very brief. 0.59. What is the ratio of the Value added (current US$) in Services in 1964 to that in 1965?
Offer a very short reply. 0.65. What is the ratio of the Value added (current US$) in Agriculture in 1964 to that in 1965?
Your response must be concise. 0.64. What is the ratio of the Value added (current US$) of Industry in 1964 to that in 1966?
Offer a very short reply. 0.66. What is the ratio of the Value added (current US$) of Manufacturing in 1964 to that in 1966?
Your answer should be compact. 0.59. What is the ratio of the Value added (current US$) of Services in 1964 to that in 1966?
Make the answer very short. 0.61. What is the ratio of the Value added (current US$) of Agriculture in 1964 to that in 1966?
Provide a short and direct response. 0.63. What is the ratio of the Value added (current US$) in Industry in 1965 to that in 1966?
Ensure brevity in your answer.  1.04. What is the ratio of the Value added (current US$) of Manufacturing in 1965 to that in 1966?
Your response must be concise. 0.99. What is the ratio of the Value added (current US$) of Services in 1965 to that in 1966?
Ensure brevity in your answer.  0.93. What is the ratio of the Value added (current US$) in Agriculture in 1965 to that in 1966?
Keep it short and to the point. 0.98. What is the difference between the highest and the second highest Value added (current US$) in Industry?
Your answer should be compact. 3.92e+06. What is the difference between the highest and the second highest Value added (current US$) in Manufacturing?
Ensure brevity in your answer.  5.60e+05. What is the difference between the highest and the second highest Value added (current US$) of Services?
Keep it short and to the point. 1.99e+07. What is the difference between the highest and the second highest Value added (current US$) of Agriculture?
Your response must be concise. 1.05e+07. What is the difference between the highest and the lowest Value added (current US$) of Industry?
Offer a terse response. 5.76e+07. What is the difference between the highest and the lowest Value added (current US$) in Manufacturing?
Offer a very short reply. 3.79e+07. What is the difference between the highest and the lowest Value added (current US$) of Services?
Provide a succinct answer. 1.55e+08. What is the difference between the highest and the lowest Value added (current US$) of Agriculture?
Provide a succinct answer. 2.24e+08. 